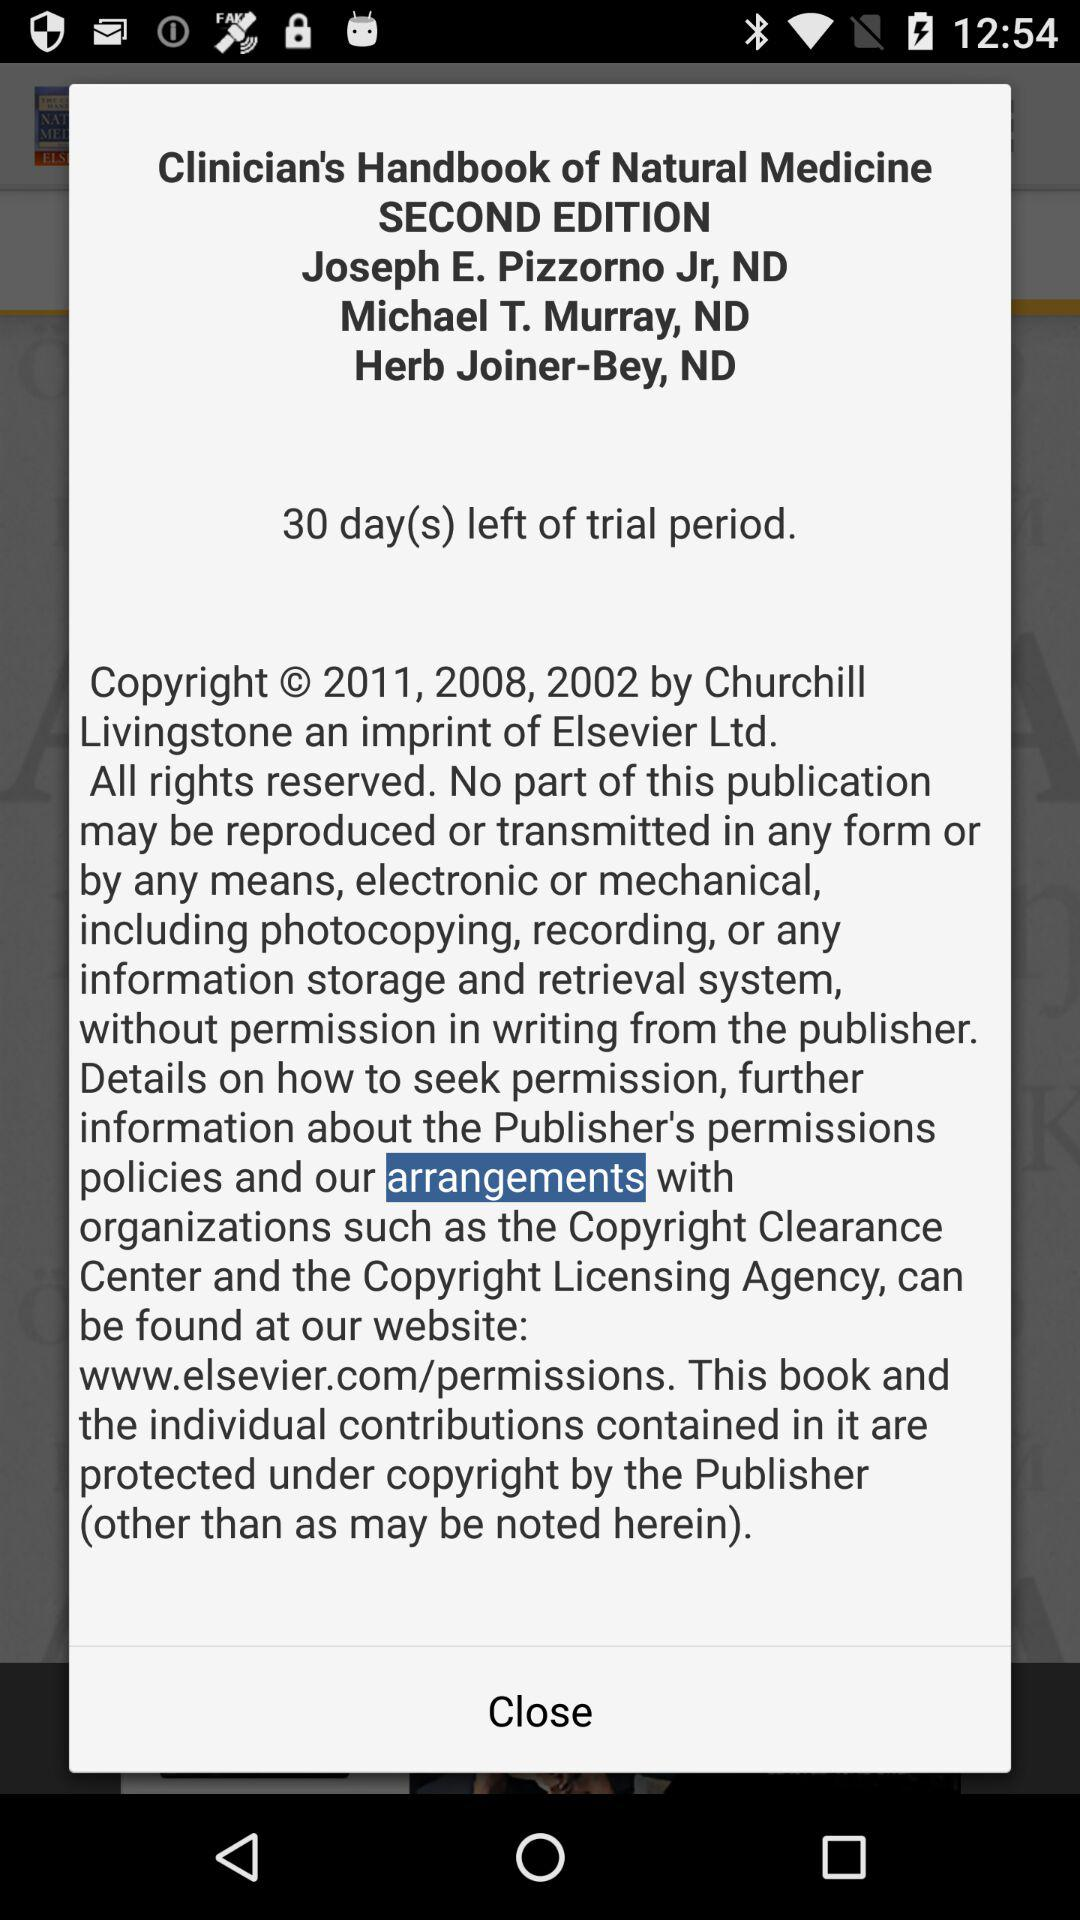What is the edition of the book? The edition of the book is second. 